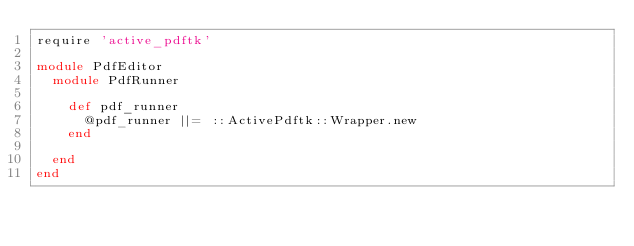Convert code to text. <code><loc_0><loc_0><loc_500><loc_500><_Ruby_>require 'active_pdftk'

module PdfEditor
  module PdfRunner

    def pdf_runner
      @pdf_runner ||= ::ActivePdftk::Wrapper.new
    end

  end
end</code> 